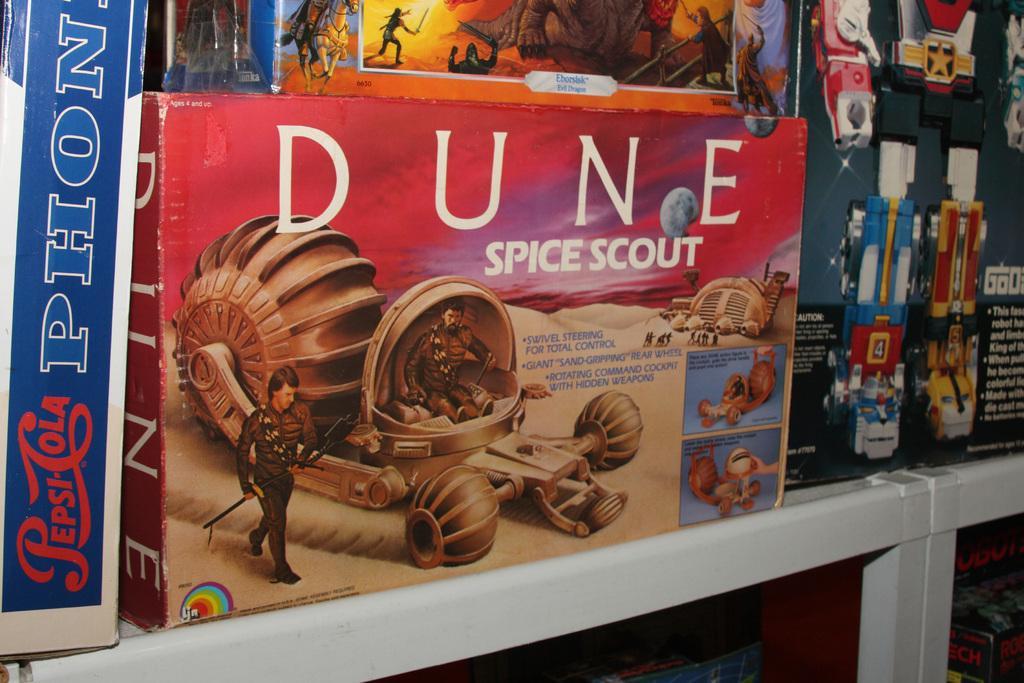Could you give a brief overview of what you see in this image? In this picture we can see a box on a platform, here we can see people, some objects and some text on it and in the background we can see some objects. 